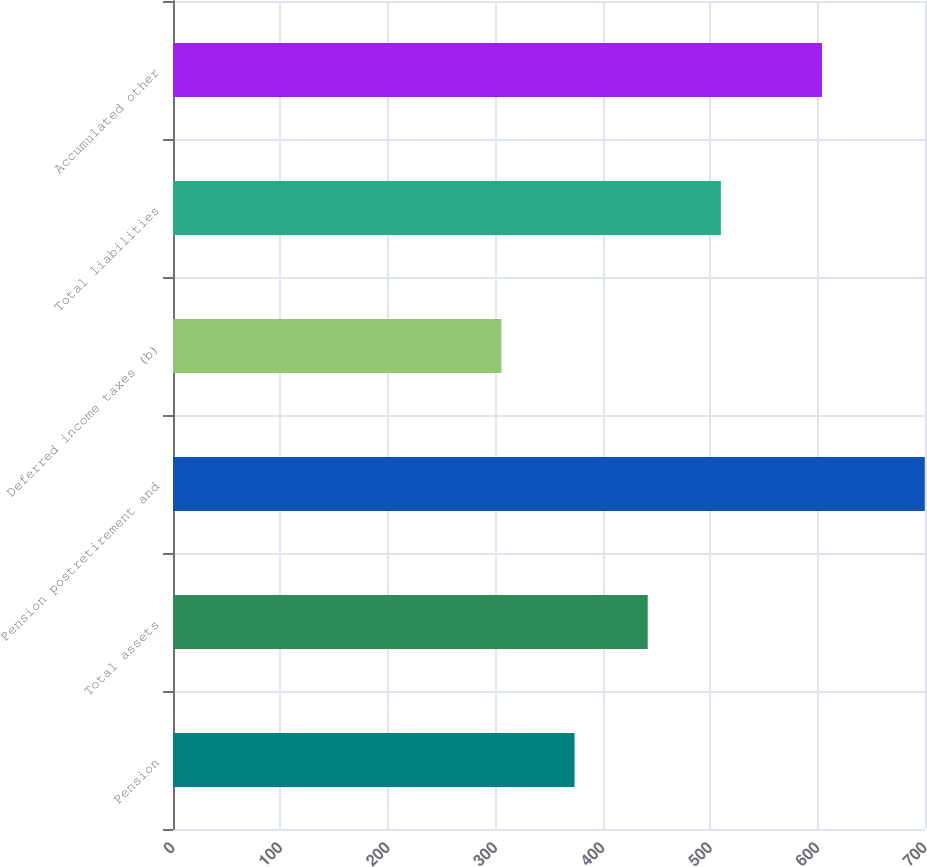Convert chart to OTSL. <chart><loc_0><loc_0><loc_500><loc_500><bar_chart><fcel>Pension<fcel>Total assets<fcel>Pension postretirement and<fcel>Deferred income taxes (b)<fcel>Total liabilities<fcel>Accumulated other<nl><fcel>373.8<fcel>441.9<fcel>699.8<fcel>305.7<fcel>510<fcel>604.1<nl></chart> 